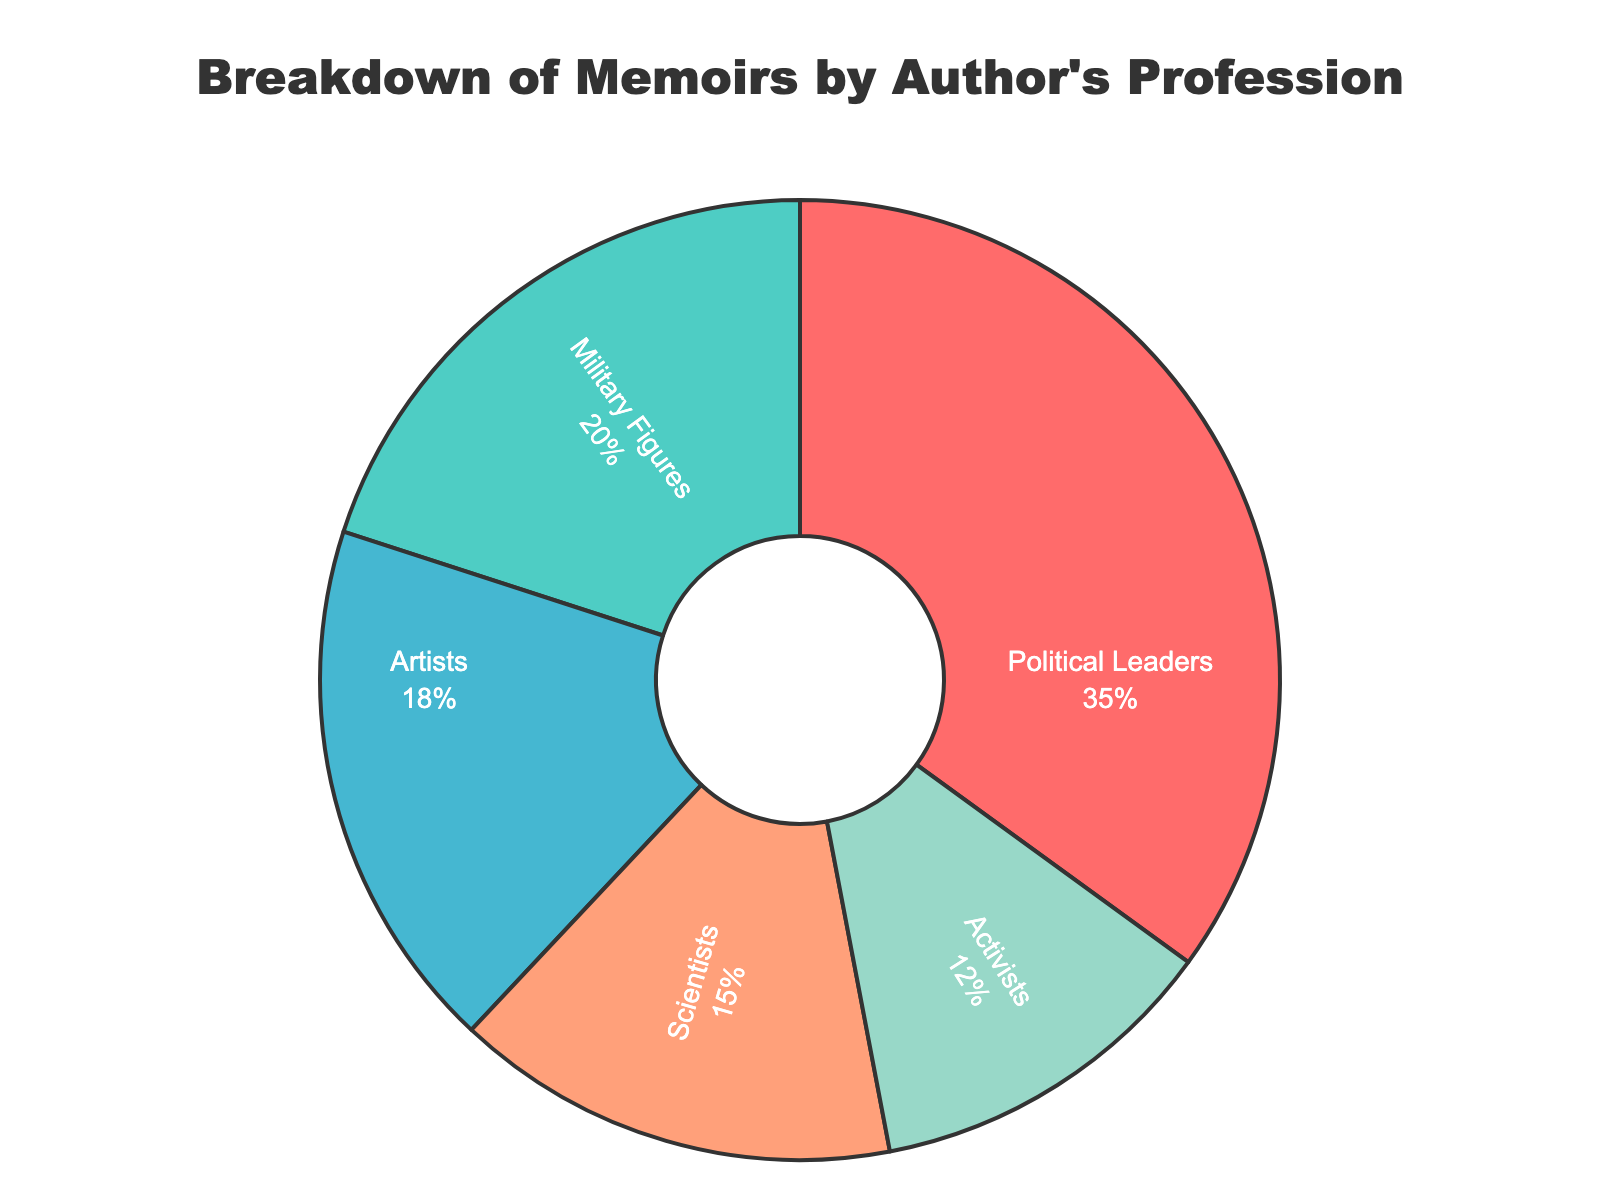what profession has the highest percentage of memoirs? The figure shows the breakdown of memoirs by profession. To find the profession with the highest percentage, look at the largest segment in the pie chart, which is labelled "Political Leaders." It indicates 35%.
Answer: Political Leaders which two professions combined make up more than half of the memoirs collected? To determine which two professions combined exceed 50%, sum the percentages of the top professions. Political Leaders (35%) + Military Figures (20%) = 55%, which is more than half.
Answer: Political Leaders and Military Figures how much greater is the percentage of memoirs by Political Leaders compared to Activists? To find the difference, subtract the smaller percentage (Activists) from the larger one (Political Leaders). 35% - 12% = 23%.
Answer: 23% what is the combined percentage of memoirs by Artists and Scientists? Add the percentages for Artists (18%) and Scientists (15%). 18% + 15% = 33%.
Answer: 33% what color represents the Scientists' memoirs in the pie chart? The pie chart uses different colors to represent each profession. According to the figure, Scientists are shown with a blue color.
Answer: Blue which profession's memoirs make up the smallest percentage of the total? The smallest segment in the pie chart is labeled "Activists," with a percentage of 12%.
Answer: Activists how much less is the percentage of memoirs by Scientists than Political Leaders and Military Figures combined? First, add the percentages of Political Leaders and Military Figures: 35% + 20% = 55%. Then, subtract the Scientists' percentage: 55% - 15% = 40%.
Answer: 40% what is the difference in the percentage of memoirs between the two smallest categories? The two smallest categories are Activists (12%) and Scientists (15%). The difference is calculated as 15% - 12% = 3%.
Answer: 3% which profession is represented by the red color in the pie chart? The pie chart uses distinct colors for each profession. The red color represents Political Leaders.
Answer: Political Leaders 